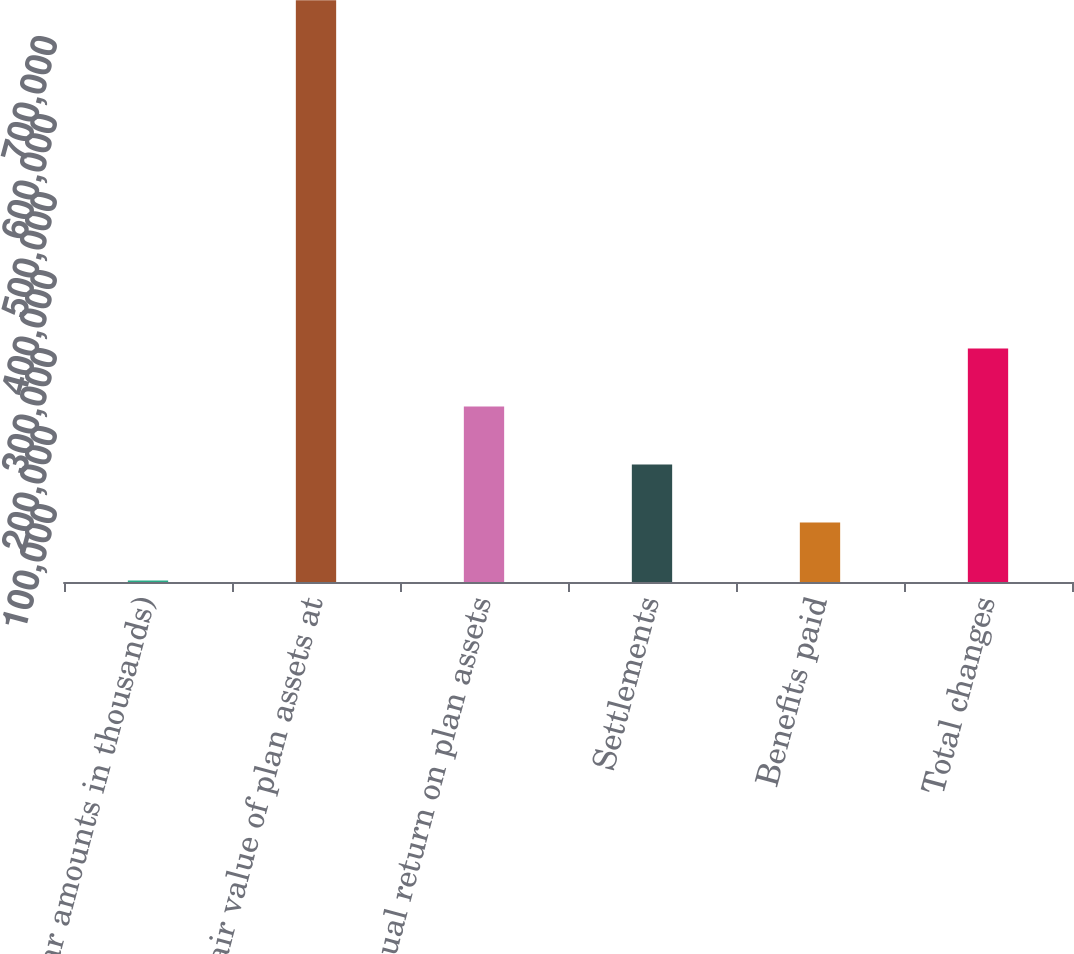Convert chart. <chart><loc_0><loc_0><loc_500><loc_500><bar_chart><fcel>(dollar amounts in thousands)<fcel>Fair value of plan assets at<fcel>Actual return on plan assets<fcel>Settlements<fcel>Benefits paid<fcel>Total changes<nl><fcel>2016<fcel>745725<fcel>225129<fcel>150758<fcel>76386.9<fcel>299500<nl></chart> 